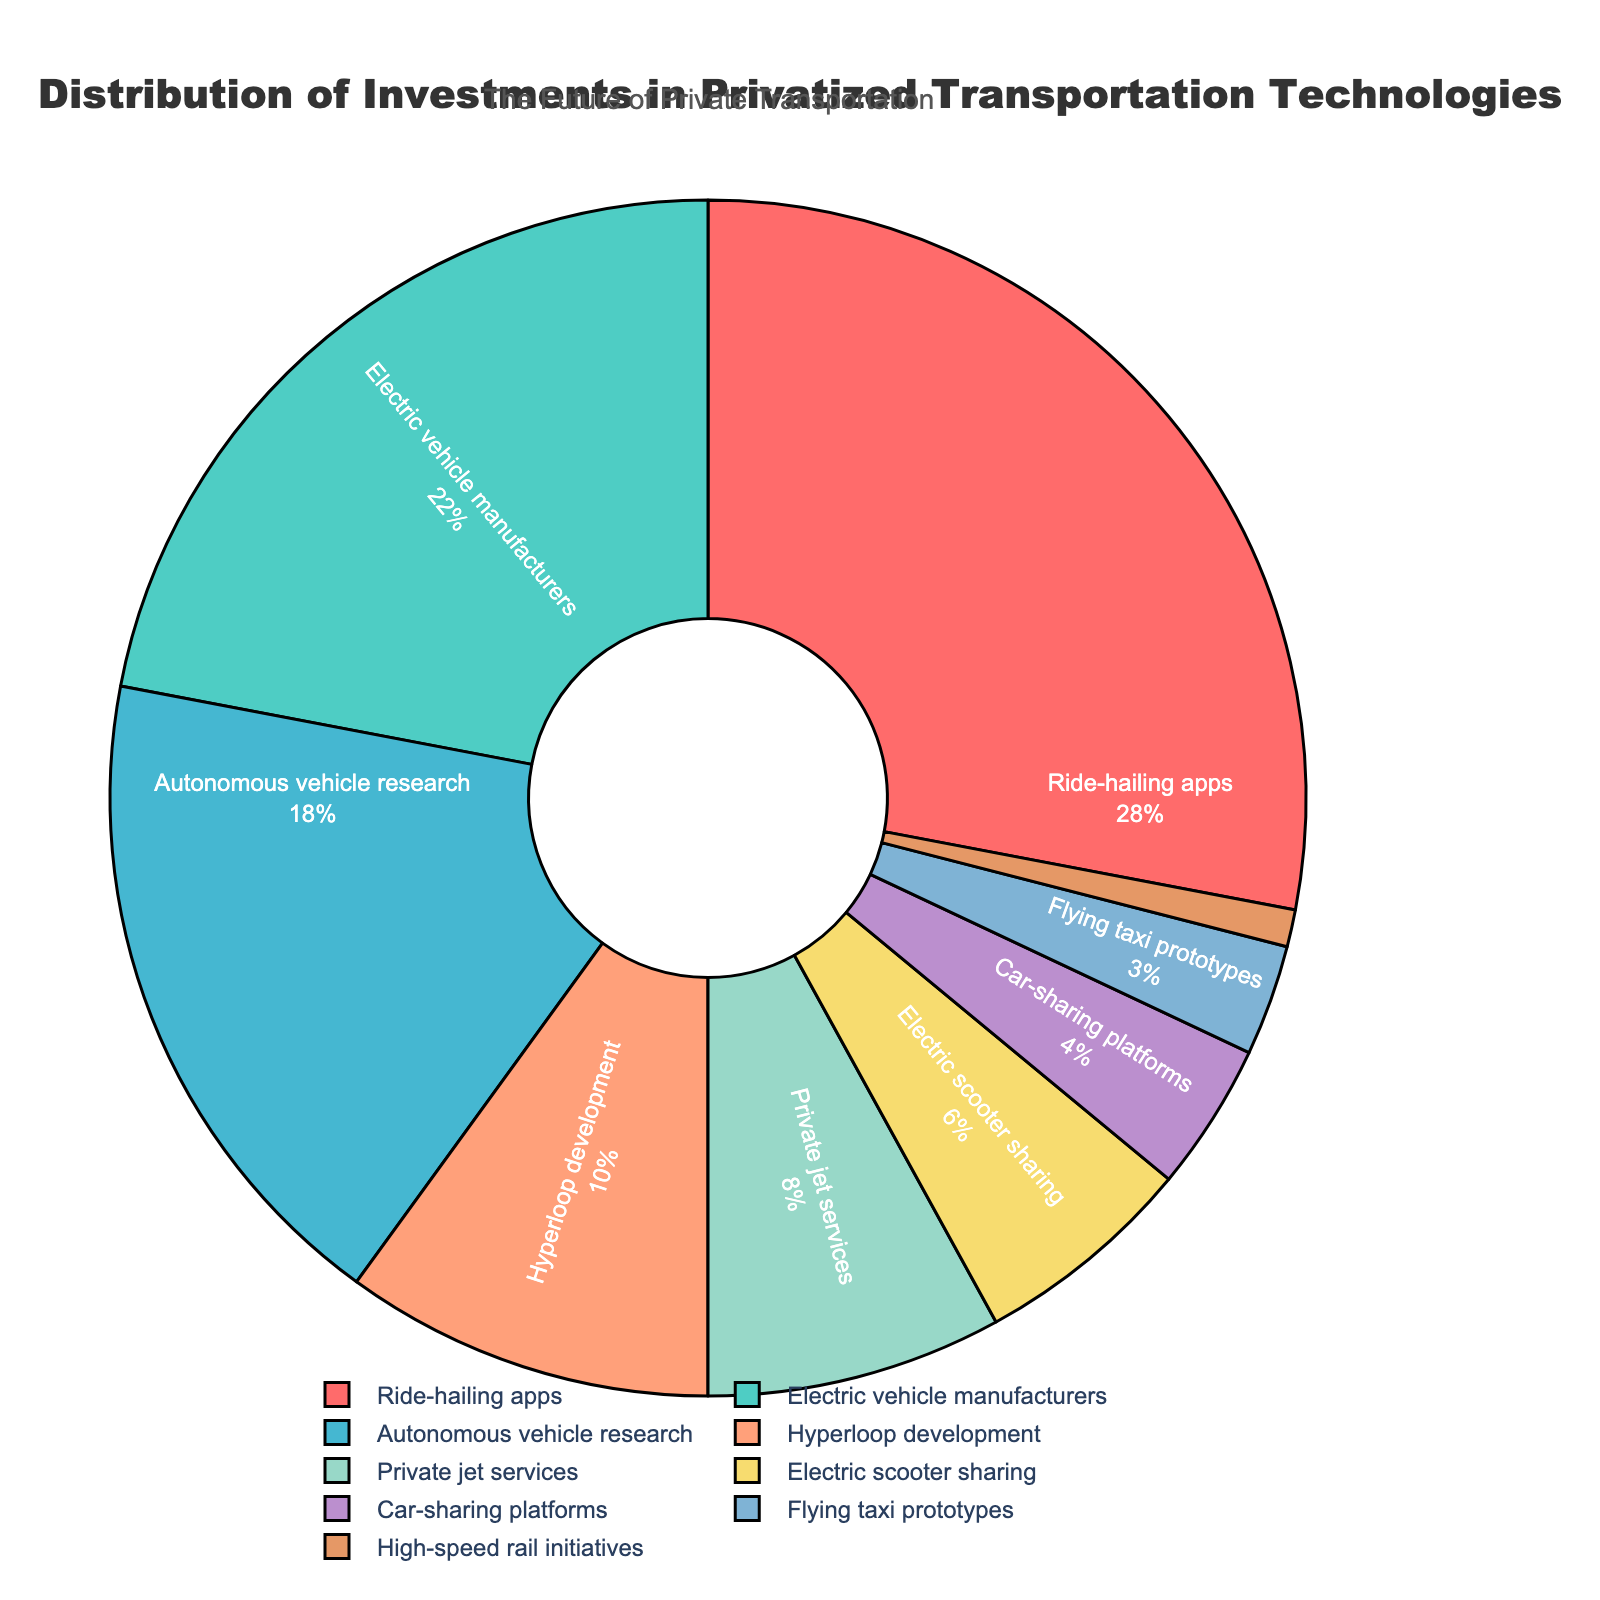What's the largest investment percentage in the pie chart? The largest investment percentage can be determined by observing the segment with the highest value in the pie chart. The segment representing Ride-hailing apps has the largest investment percentage of 28%.
Answer: 28% Which transportation technology receives more investment: Hyperloop development or Autonomous vehicle research? Compare the segments representing Hyperloop development and Autonomous vehicle research in the pie chart. Hyperloop development has 10%, and Autonomous vehicle research has 18%. Therefore, Autonomous vehicle research receives more investment.
Answer: Autonomous vehicle research What's the total investment percentage for Electric vehicle manufacturers and Electric scooter sharing combined? Add the investment percentages for Electric vehicle manufacturers and Electric scooter sharing. Electric vehicle manufacturers have 22%, and Electric scooter sharing has 6%. 22% + 6% = 28%.
Answer: 28% Which segment has the smallest investment percentage, and what is it? Identify the segment with the smallest proportion in the pie chart. The High-speed rail initiatives segment has the smallest investment percentage of 1%.
Answer: High-speed rail initiatives, 1% What is the difference in investment percentage between Ride-hailing apps and Private jet services? Subtract the investment percentage of Private jet services from that of Ride-hailing apps. Ride-hailing apps have 28%, and Private jet services have 8%. 28% - 8% = 20%.
Answer: 20% What proportion of the investments is allocated to technologies related to electric vehicles (both Electric vehicle manufacturers and Electric scooter sharing)? Combine the investment percentages for Electric vehicle manufacturers and Electric scooter sharing. Electric vehicle manufacturers have 22%, and Electric scooter sharing has 6%. 22% + 6% = 28%.
Answer: 28% How does the investment in Car-sharing platforms compare to that of Flying taxi prototypes? Check the pie chart segments for Car-sharing platforms and Flying taxi prototypes. Car-sharing platforms have an investment percentage of 4%, while Flying taxi prototypes have 3%. Car-sharing platforms have a slightly higher investment.
Answer: Car-sharing platforms What's the combined investment percentage for transportation technologies related to autonomous movements (Autonomous vehicle research and Flying taxi prototypes)? Add the investment percentages for Autonomous vehicle research and Flying taxi prototypes. Autonomous vehicle research has 18%, and Flying taxi prototypes have 3%. 18% + 3% = 21%.
Answer: 21% What's the average investment percentage across all technologies? Sum the investment percentages for all technologies and divide by the number of technologies. (28% + 22% + 18% + 10% + 8% + 6% + 4% + 3% + 1%) / 9 = 11.11%.
Answer: 11.11% Which technology's segment is displayed in light green color on the pie chart? Observe the color palette used in the pie chart, identify the light green segment, and check the corresponding technology label. The light green color represents Hyperloop development.
Answer: Hyperloop development 